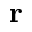Convert formula to latex. <formula><loc_0><loc_0><loc_500><loc_500>r</formula> 